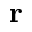Convert formula to latex. <formula><loc_0><loc_0><loc_500><loc_500>r</formula> 